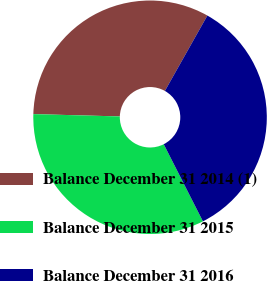<chart> <loc_0><loc_0><loc_500><loc_500><pie_chart><fcel>Balance December 31 2014 (1)<fcel>Balance December 31 2015<fcel>Balance December 31 2016<nl><fcel>32.74%<fcel>32.91%<fcel>34.35%<nl></chart> 